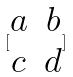Convert formula to latex. <formula><loc_0><loc_0><loc_500><loc_500>[ \begin{matrix} a & b \\ c & d \\ \end{matrix} ]</formula> 